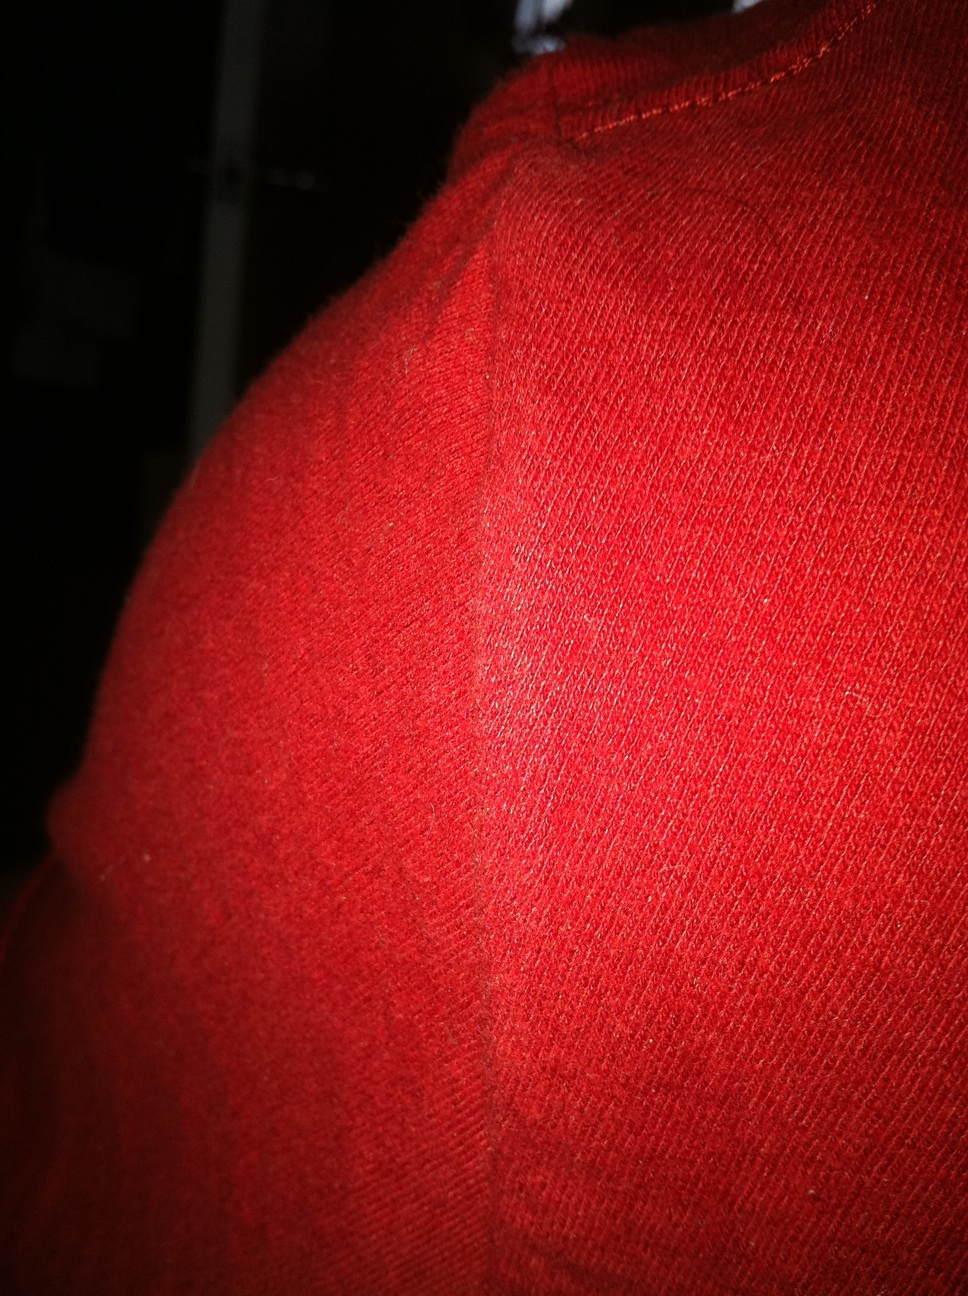A very creative question, what if this red fabric could transport someone to a different world? Where would it take them? Imagine this red fabric as a magical portal, transporting anyone who wraps themselves in it to the enchanting land of Pyrolandia. This realm is a lush, endless autumn where trees are forever draped in shades of red and gold, and the air is crisp with the scent of cinnamon and cloves. Crimson skies glow softly with the light of perpetual sunsets. In Pyrolandia, every river sparkles with the essence of warm cider, and cozy cottages dot the landscape, filled with the laughter of friends and the warmth of endless hearth fires. Here, the fabric offers more than just physical warmth; it envelops you in a sense of joyful nostalgia and eternal comfort. 